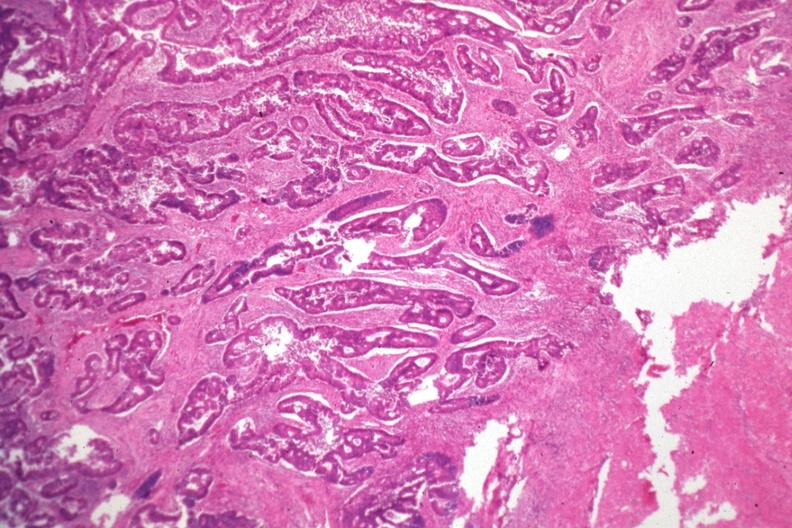what is present?
Answer the question using a single word or phrase. Gastrointestinal 